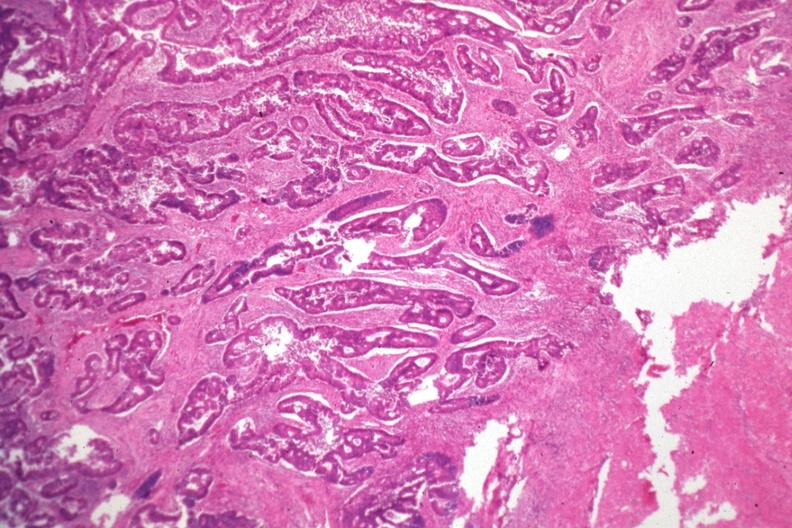what is present?
Answer the question using a single word or phrase. Gastrointestinal 